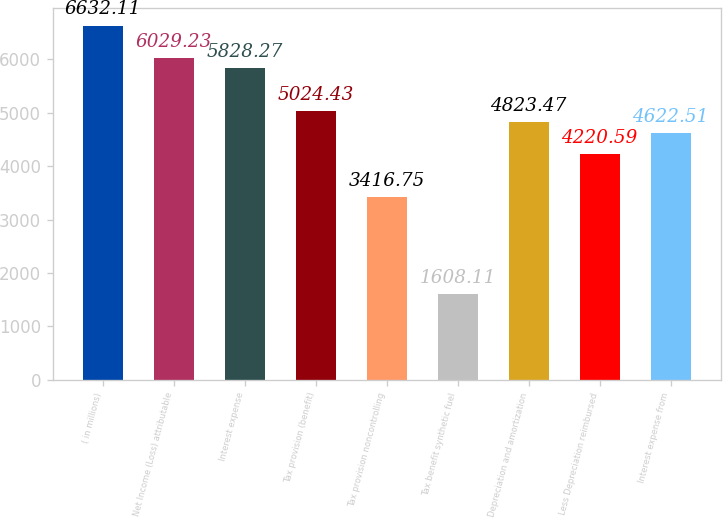Convert chart to OTSL. <chart><loc_0><loc_0><loc_500><loc_500><bar_chart><fcel>( in millions)<fcel>Net Income (Loss) attributable<fcel>Interest expense<fcel>Tax provision (benefit)<fcel>Tax provision noncontrolling<fcel>Tax benefit synthetic fuel<fcel>Depreciation and amortization<fcel>Less Depreciation reimbursed<fcel>Interest expense from<nl><fcel>6632.11<fcel>6029.23<fcel>5828.27<fcel>5024.43<fcel>3416.75<fcel>1608.11<fcel>4823.47<fcel>4220.59<fcel>4622.51<nl></chart> 